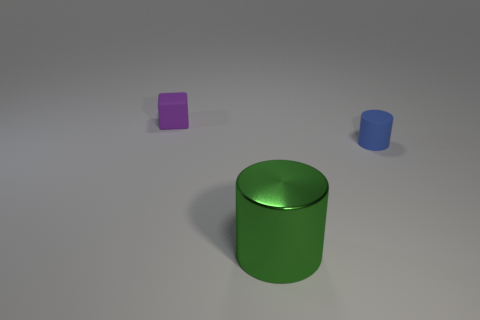Are there any other things that are the same material as the big object?
Your answer should be compact. No. What number of other things have the same shape as the blue rubber thing?
Offer a very short reply. 1. The blue object has what shape?
Your answer should be compact. Cylinder. Is the number of tiny purple objects less than the number of matte objects?
Your response must be concise. Yes. Is there any other thing that is the same size as the metal thing?
Offer a very short reply. No. There is a large object that is the same shape as the small blue matte object; what is it made of?
Your answer should be compact. Metal. Are there more small blocks than small rubber objects?
Ensure brevity in your answer.  No. Is the cube made of the same material as the small object that is in front of the purple block?
Your response must be concise. Yes. There is a rubber object that is behind the cylinder that is behind the large thing; how many blue rubber cylinders are to the right of it?
Give a very brief answer. 1. Are there fewer small cylinders that are left of the large green cylinder than matte objects behind the matte cylinder?
Make the answer very short. Yes. 